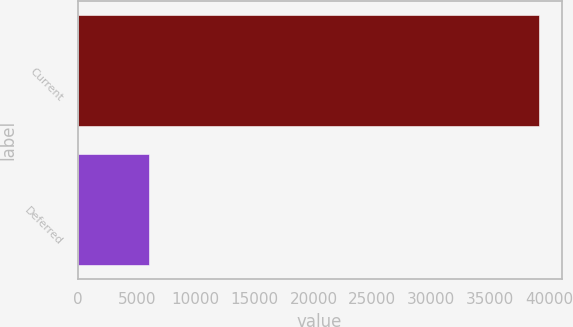Convert chart to OTSL. <chart><loc_0><loc_0><loc_500><loc_500><bar_chart><fcel>Current<fcel>Deferred<nl><fcel>39096<fcel>6053<nl></chart> 